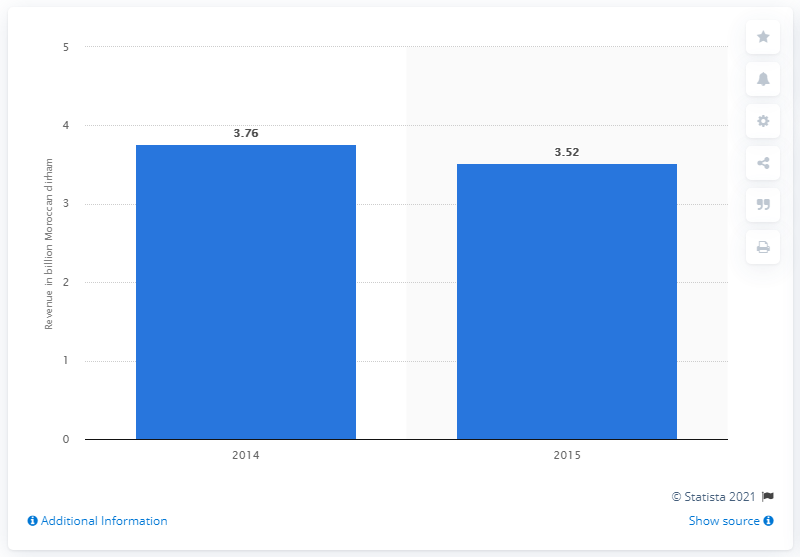Identify some key points in this picture. In 2014, the publishing industry in Morocco generated approximately 3.76 billion dirhams in revenue. 